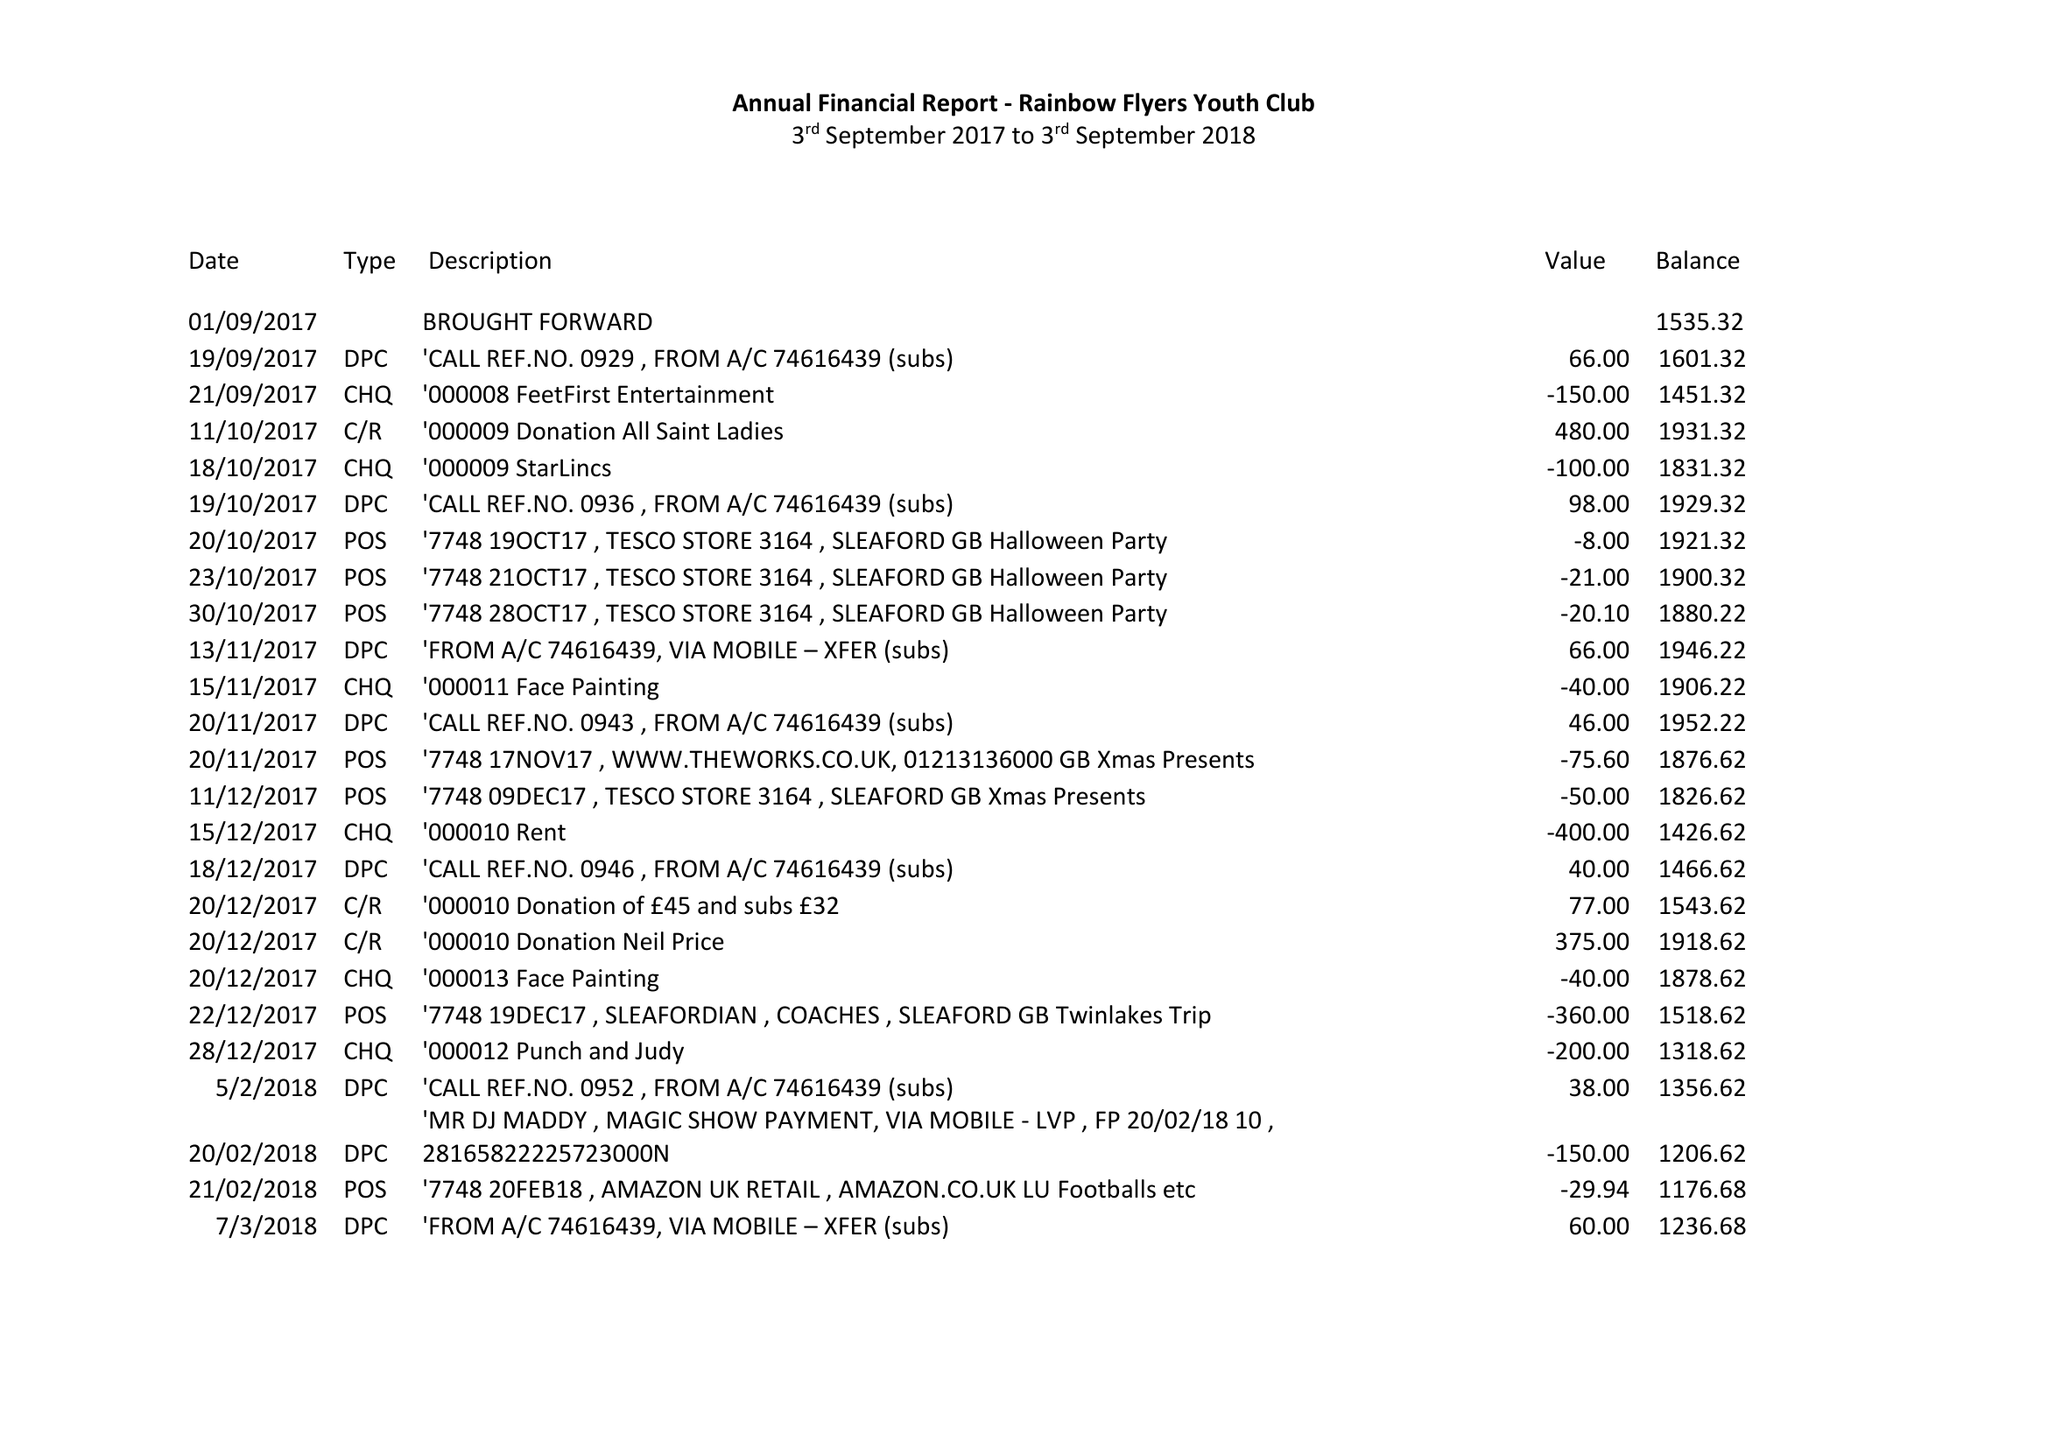What is the value for the income_annually_in_british_pounds?
Answer the question using a single word or phrase. 3945.00 